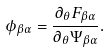Convert formula to latex. <formula><loc_0><loc_0><loc_500><loc_500>\phi _ { \beta \alpha } = \frac { \partial _ { \theta } F _ { \beta \alpha } } { \partial _ { \theta } \Psi _ { \beta \alpha } } .</formula> 